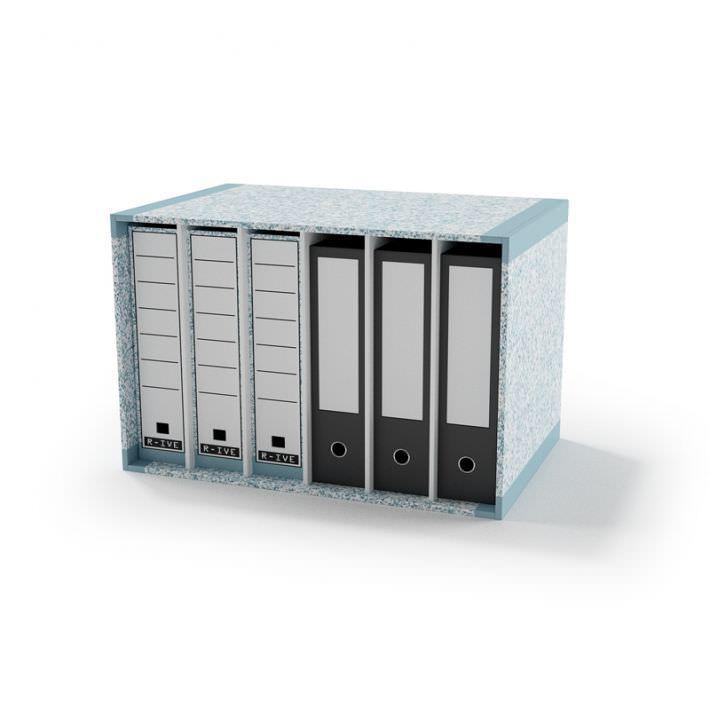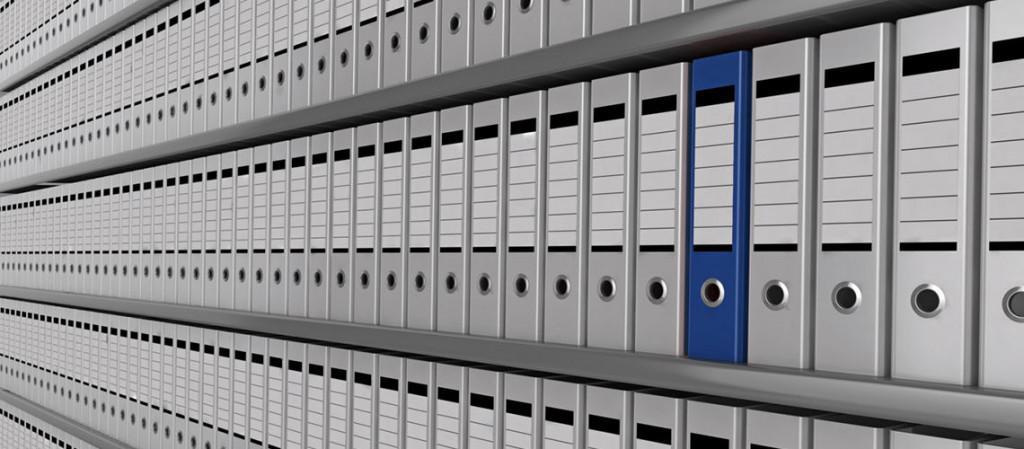The first image is the image on the left, the second image is the image on the right. For the images displayed, is the sentence "One image shows a binder both open and closed, while the other image shows a closed binder in two to four color options." factually correct? Answer yes or no. No. 